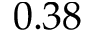<formula> <loc_0><loc_0><loc_500><loc_500>0 . 3 8</formula> 